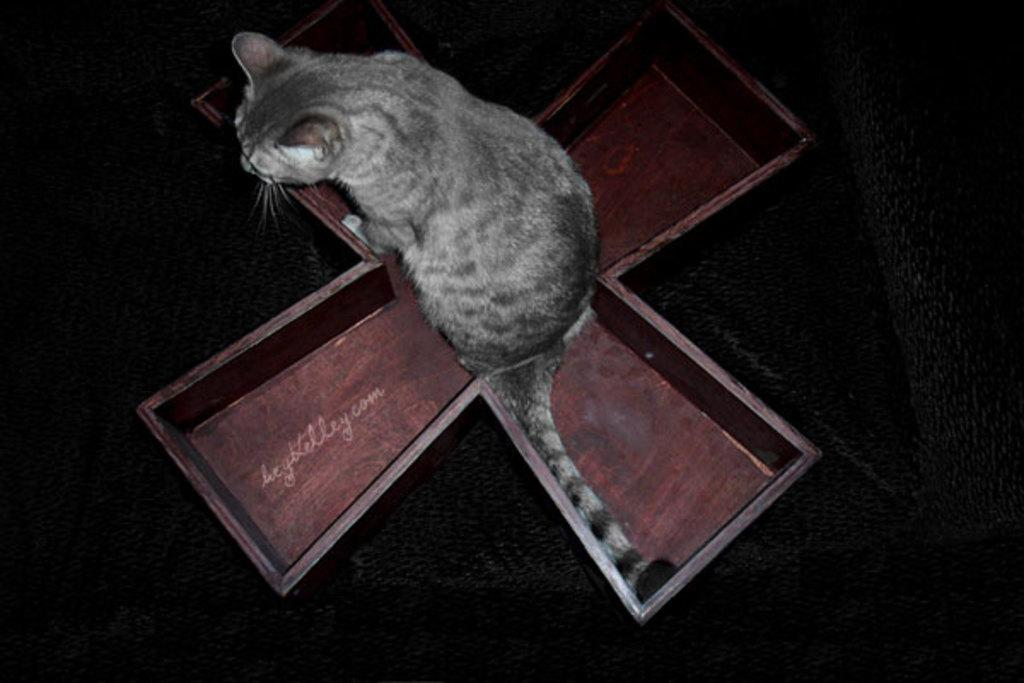What type of animal is in the image? There is a cat in the image. Where is the cat located in the image? The cat is in the middle of the image. What is under the cat in the image? There is an object under the cat. How many bridges can be seen in the image? There are no bridges present in the image; it features a cat in the middle with an object underneath. What type of nose is visible on the cat in the image? Cats do not have human-like noses, so there is no specific type of nose to describe on the cat in the image. 